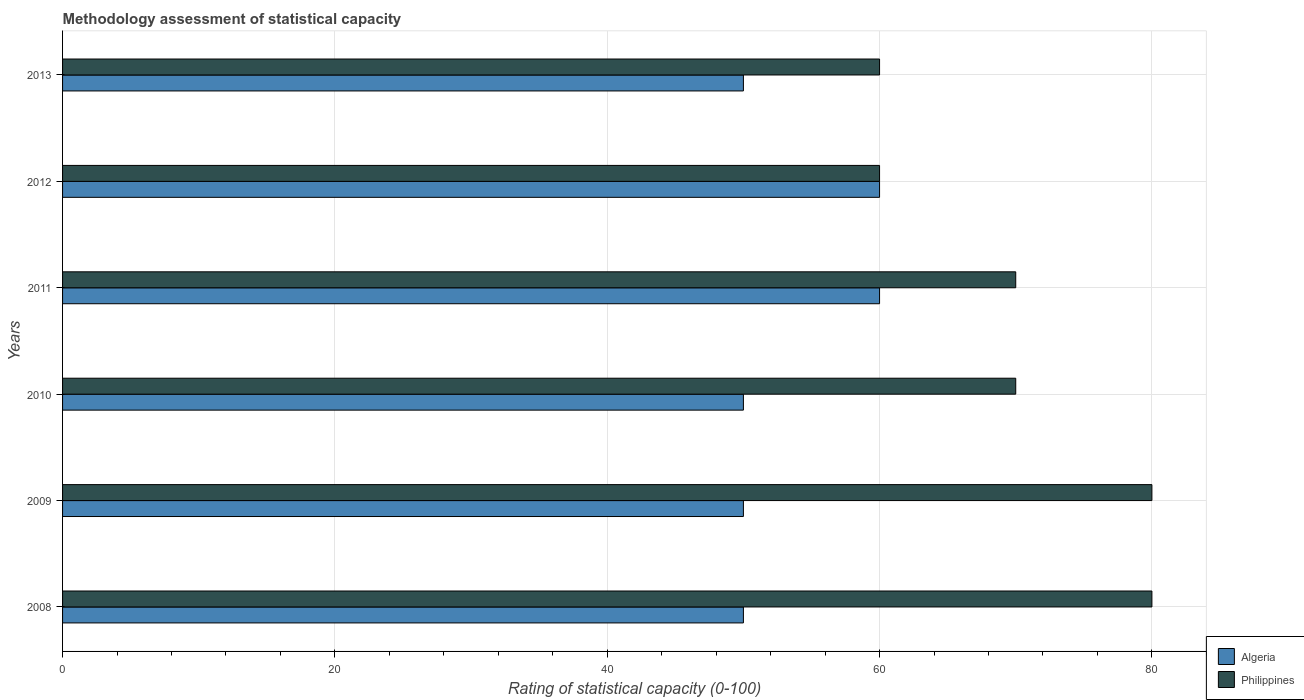How many different coloured bars are there?
Provide a short and direct response. 2. Are the number of bars on each tick of the Y-axis equal?
Ensure brevity in your answer.  Yes. What is the label of the 3rd group of bars from the top?
Keep it short and to the point. 2011. In how many cases, is the number of bars for a given year not equal to the number of legend labels?
Your answer should be very brief. 0. What is the rating of statistical capacity in Algeria in 2013?
Keep it short and to the point. 50. Across all years, what is the maximum rating of statistical capacity in Philippines?
Your response must be concise. 80. Across all years, what is the minimum rating of statistical capacity in Algeria?
Your answer should be compact. 50. In which year was the rating of statistical capacity in Algeria maximum?
Give a very brief answer. 2011. In which year was the rating of statistical capacity in Philippines minimum?
Make the answer very short. 2012. What is the total rating of statistical capacity in Philippines in the graph?
Your answer should be compact. 420. What is the difference between the rating of statistical capacity in Philippines in 2008 and that in 2013?
Make the answer very short. 20. What is the difference between the rating of statistical capacity in Philippines in 2010 and the rating of statistical capacity in Algeria in 2009?
Your response must be concise. 20. In the year 2008, what is the difference between the rating of statistical capacity in Algeria and rating of statistical capacity in Philippines?
Your response must be concise. -30. In how many years, is the rating of statistical capacity in Philippines greater than 20 ?
Ensure brevity in your answer.  6. What is the ratio of the rating of statistical capacity in Algeria in 2011 to that in 2013?
Give a very brief answer. 1.2. What is the difference between the highest and the lowest rating of statistical capacity in Algeria?
Provide a succinct answer. 10. In how many years, is the rating of statistical capacity in Philippines greater than the average rating of statistical capacity in Philippines taken over all years?
Ensure brevity in your answer.  2. What does the 1st bar from the bottom in 2008 represents?
Offer a very short reply. Algeria. How many years are there in the graph?
Provide a succinct answer. 6. Are the values on the major ticks of X-axis written in scientific E-notation?
Keep it short and to the point. No. Does the graph contain grids?
Offer a very short reply. Yes. How many legend labels are there?
Give a very brief answer. 2. What is the title of the graph?
Make the answer very short. Methodology assessment of statistical capacity. Does "Senegal" appear as one of the legend labels in the graph?
Offer a terse response. No. What is the label or title of the X-axis?
Make the answer very short. Rating of statistical capacity (0-100). What is the Rating of statistical capacity (0-100) of Philippines in 2008?
Provide a succinct answer. 80. What is the Rating of statistical capacity (0-100) of Algeria in 2009?
Give a very brief answer. 50. What is the Rating of statistical capacity (0-100) in Philippines in 2009?
Give a very brief answer. 80. What is the Rating of statistical capacity (0-100) of Algeria in 2011?
Your response must be concise. 60. What is the Rating of statistical capacity (0-100) of Philippines in 2011?
Keep it short and to the point. 70. What is the Rating of statistical capacity (0-100) of Algeria in 2012?
Provide a short and direct response. 60. What is the Rating of statistical capacity (0-100) of Philippines in 2012?
Offer a very short reply. 60. What is the Rating of statistical capacity (0-100) in Algeria in 2013?
Provide a succinct answer. 50. What is the Rating of statistical capacity (0-100) in Philippines in 2013?
Your answer should be compact. 60. Across all years, what is the maximum Rating of statistical capacity (0-100) of Algeria?
Your answer should be compact. 60. Across all years, what is the minimum Rating of statistical capacity (0-100) of Algeria?
Make the answer very short. 50. What is the total Rating of statistical capacity (0-100) in Algeria in the graph?
Your answer should be compact. 320. What is the total Rating of statistical capacity (0-100) of Philippines in the graph?
Offer a very short reply. 420. What is the difference between the Rating of statistical capacity (0-100) in Philippines in 2008 and that in 2009?
Offer a terse response. 0. What is the difference between the Rating of statistical capacity (0-100) of Algeria in 2008 and that in 2010?
Keep it short and to the point. 0. What is the difference between the Rating of statistical capacity (0-100) in Philippines in 2008 and that in 2010?
Provide a short and direct response. 10. What is the difference between the Rating of statistical capacity (0-100) of Philippines in 2008 and that in 2011?
Provide a succinct answer. 10. What is the difference between the Rating of statistical capacity (0-100) of Algeria in 2008 and that in 2012?
Make the answer very short. -10. What is the difference between the Rating of statistical capacity (0-100) of Algeria in 2008 and that in 2013?
Provide a succinct answer. 0. What is the difference between the Rating of statistical capacity (0-100) of Philippines in 2008 and that in 2013?
Make the answer very short. 20. What is the difference between the Rating of statistical capacity (0-100) of Algeria in 2009 and that in 2010?
Your answer should be compact. 0. What is the difference between the Rating of statistical capacity (0-100) in Philippines in 2009 and that in 2010?
Your answer should be compact. 10. What is the difference between the Rating of statistical capacity (0-100) of Algeria in 2009 and that in 2011?
Your answer should be very brief. -10. What is the difference between the Rating of statistical capacity (0-100) of Philippines in 2009 and that in 2011?
Your answer should be compact. 10. What is the difference between the Rating of statistical capacity (0-100) of Algeria in 2009 and that in 2013?
Your answer should be very brief. 0. What is the difference between the Rating of statistical capacity (0-100) of Algeria in 2010 and that in 2011?
Make the answer very short. -10. What is the difference between the Rating of statistical capacity (0-100) of Philippines in 2010 and that in 2011?
Offer a very short reply. 0. What is the difference between the Rating of statistical capacity (0-100) in Philippines in 2010 and that in 2012?
Offer a terse response. 10. What is the difference between the Rating of statistical capacity (0-100) in Algeria in 2010 and that in 2013?
Give a very brief answer. 0. What is the difference between the Rating of statistical capacity (0-100) in Algeria in 2011 and that in 2012?
Your answer should be compact. 0. What is the difference between the Rating of statistical capacity (0-100) of Philippines in 2011 and that in 2013?
Keep it short and to the point. 10. What is the difference between the Rating of statistical capacity (0-100) in Algeria in 2008 and the Rating of statistical capacity (0-100) in Philippines in 2009?
Keep it short and to the point. -30. What is the difference between the Rating of statistical capacity (0-100) of Algeria in 2008 and the Rating of statistical capacity (0-100) of Philippines in 2013?
Your answer should be very brief. -10. What is the difference between the Rating of statistical capacity (0-100) in Algeria in 2009 and the Rating of statistical capacity (0-100) in Philippines in 2012?
Keep it short and to the point. -10. What is the difference between the Rating of statistical capacity (0-100) in Algeria in 2009 and the Rating of statistical capacity (0-100) in Philippines in 2013?
Offer a terse response. -10. What is the difference between the Rating of statistical capacity (0-100) in Algeria in 2010 and the Rating of statistical capacity (0-100) in Philippines in 2011?
Make the answer very short. -20. What is the difference between the Rating of statistical capacity (0-100) in Algeria in 2010 and the Rating of statistical capacity (0-100) in Philippines in 2012?
Offer a very short reply. -10. What is the difference between the Rating of statistical capacity (0-100) in Algeria in 2012 and the Rating of statistical capacity (0-100) in Philippines in 2013?
Offer a terse response. 0. What is the average Rating of statistical capacity (0-100) in Algeria per year?
Keep it short and to the point. 53.33. In the year 2008, what is the difference between the Rating of statistical capacity (0-100) of Algeria and Rating of statistical capacity (0-100) of Philippines?
Keep it short and to the point. -30. In the year 2013, what is the difference between the Rating of statistical capacity (0-100) of Algeria and Rating of statistical capacity (0-100) of Philippines?
Offer a very short reply. -10. What is the ratio of the Rating of statistical capacity (0-100) of Philippines in 2008 to that in 2009?
Your answer should be very brief. 1. What is the ratio of the Rating of statistical capacity (0-100) in Algeria in 2008 to that in 2010?
Provide a short and direct response. 1. What is the ratio of the Rating of statistical capacity (0-100) in Philippines in 2008 to that in 2011?
Ensure brevity in your answer.  1.14. What is the ratio of the Rating of statistical capacity (0-100) in Algeria in 2008 to that in 2012?
Keep it short and to the point. 0.83. What is the ratio of the Rating of statistical capacity (0-100) in Philippines in 2008 to that in 2013?
Your answer should be compact. 1.33. What is the ratio of the Rating of statistical capacity (0-100) of Algeria in 2009 to that in 2010?
Your answer should be very brief. 1. What is the ratio of the Rating of statistical capacity (0-100) of Philippines in 2009 to that in 2010?
Give a very brief answer. 1.14. What is the ratio of the Rating of statistical capacity (0-100) in Algeria in 2009 to that in 2011?
Make the answer very short. 0.83. What is the ratio of the Rating of statistical capacity (0-100) in Algeria in 2009 to that in 2012?
Give a very brief answer. 0.83. What is the ratio of the Rating of statistical capacity (0-100) of Philippines in 2010 to that in 2011?
Keep it short and to the point. 1. What is the ratio of the Rating of statistical capacity (0-100) in Philippines in 2010 to that in 2012?
Offer a terse response. 1.17. What is the ratio of the Rating of statistical capacity (0-100) in Algeria in 2010 to that in 2013?
Your answer should be very brief. 1. What is the ratio of the Rating of statistical capacity (0-100) of Algeria in 2011 to that in 2012?
Give a very brief answer. 1. What is the ratio of the Rating of statistical capacity (0-100) of Philippines in 2012 to that in 2013?
Give a very brief answer. 1. What is the difference between the highest and the second highest Rating of statistical capacity (0-100) in Algeria?
Your answer should be very brief. 0. What is the difference between the highest and the second highest Rating of statistical capacity (0-100) in Philippines?
Your answer should be compact. 0. What is the difference between the highest and the lowest Rating of statistical capacity (0-100) of Algeria?
Keep it short and to the point. 10. 